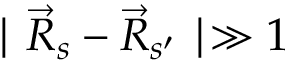Convert formula to latex. <formula><loc_0><loc_0><loc_500><loc_500>| \vec { R } _ { s } - \vec { R } _ { s ^ { \prime } } | \gg 1</formula> 